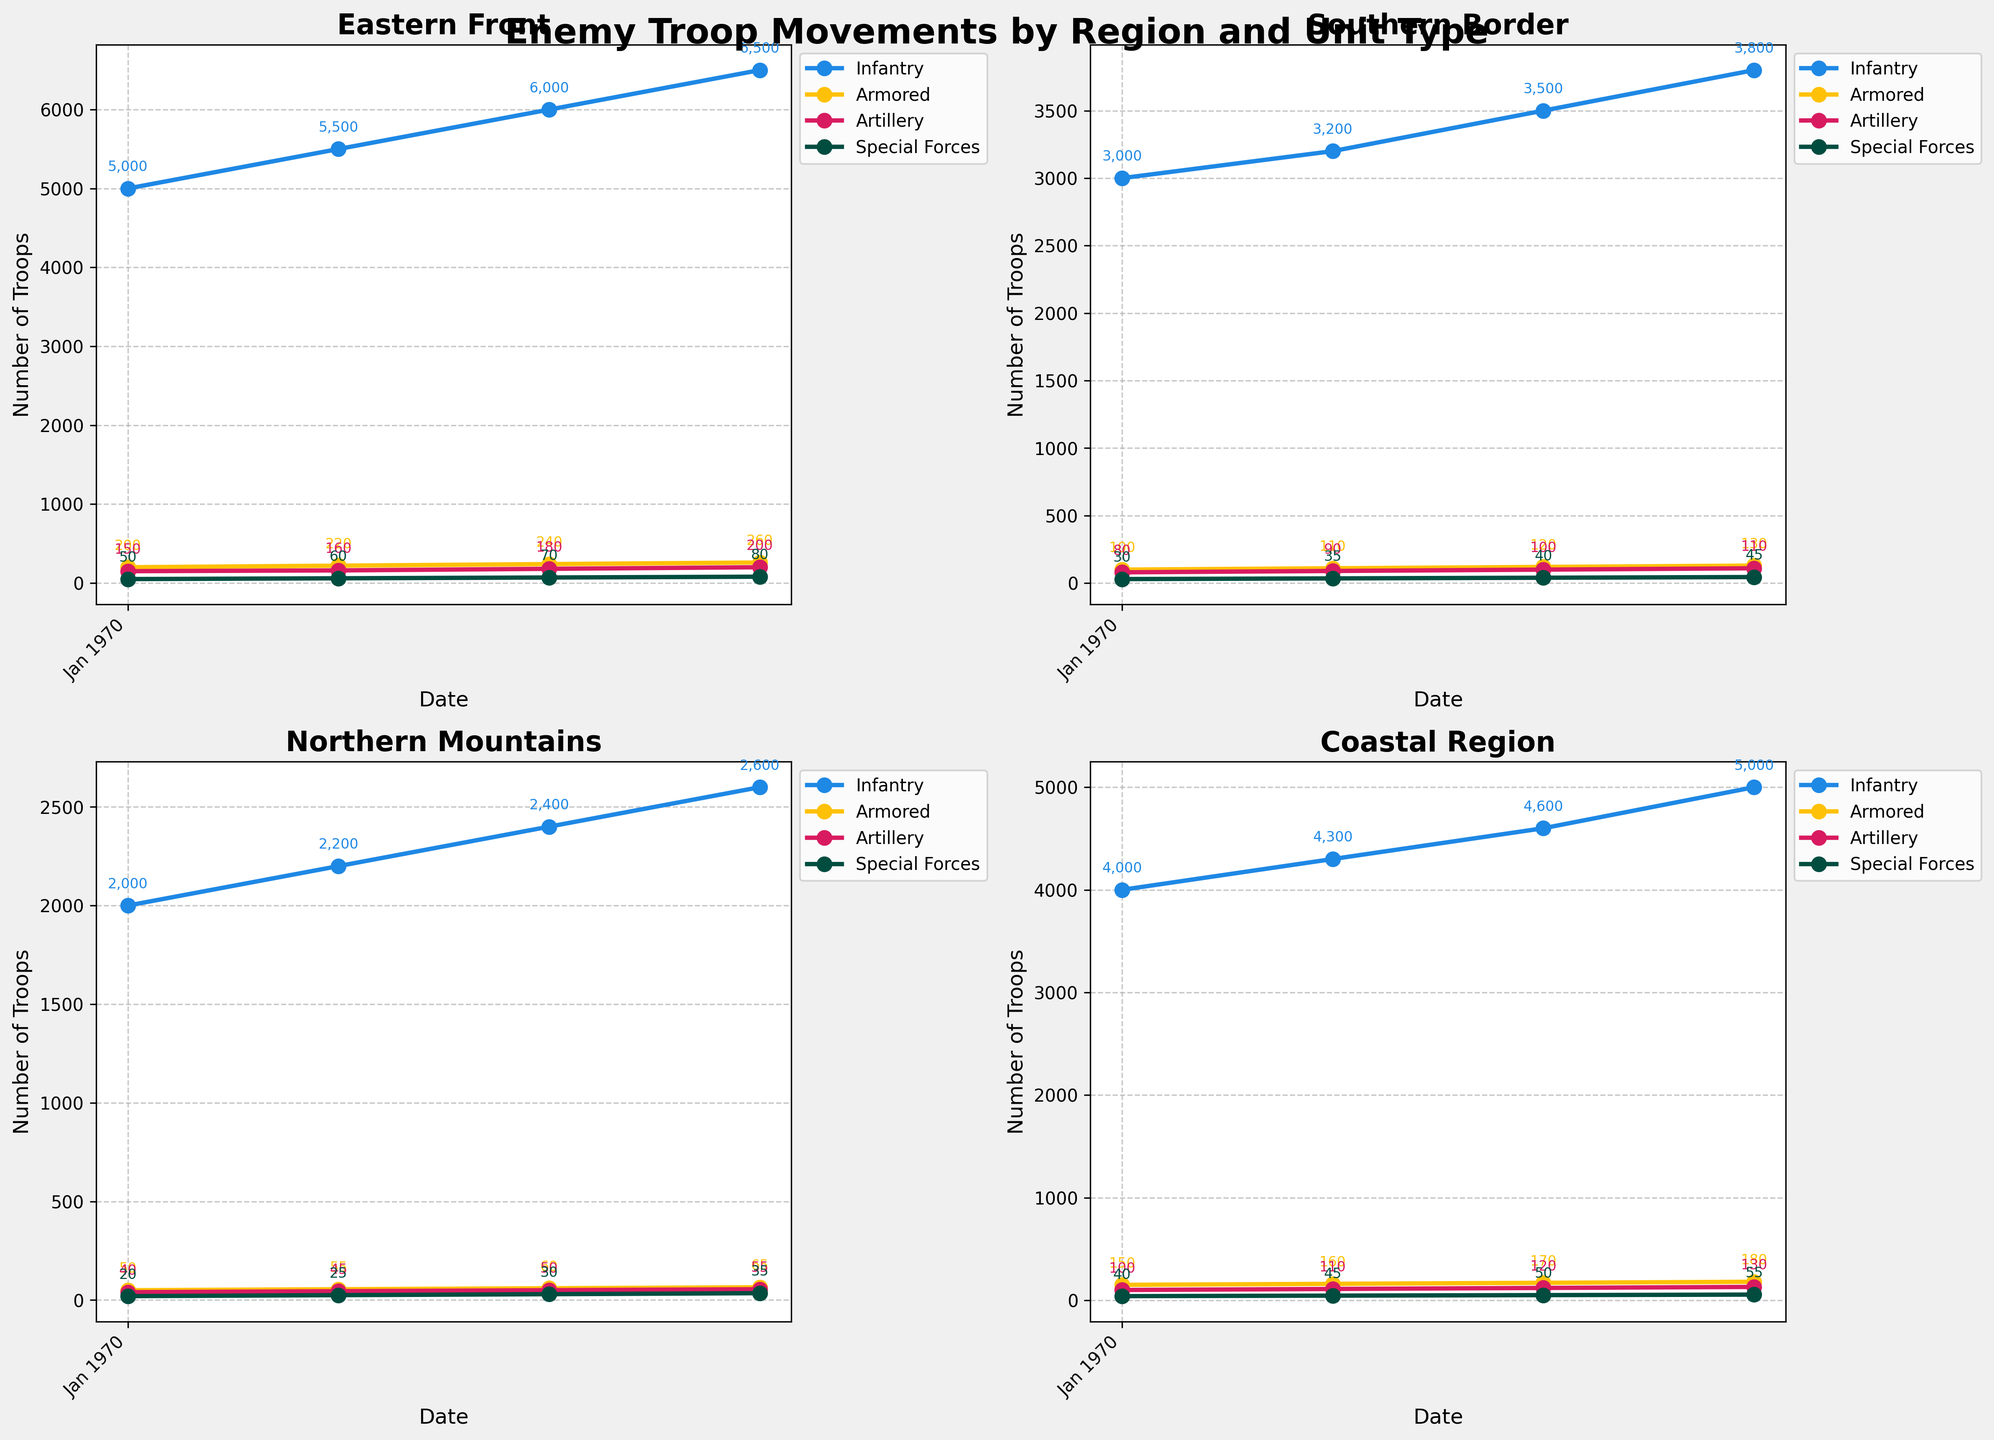What is the trend of Infantry troop movement in the Eastern Front from January to April 2023? By examining the line for Infantry in the Eastern Front subplot, we can see a steady increase from 5,000 in January to 6,500 in April.
Answer: Increasing Which region has the highest number of Armored units in April 2023? By comparing the data points for April 2023 in each subplot, the Coastal Region shows the highest number of Armored units with 180.
Answer: Coastal Region Compare the difference between the number of Artillery units in the Northern Mountains and the Southern Border in February 2023. The number of Artillery units in February 2023 is 55 in the Northern Mountains and 110 in the Southern Border. The difference is 110 - 55 = 55.
Answer: 55 What is the combined total of Special Forces units across all regions in March 2023? Sum the values in March 2023 for each region: 70 (Eastern Front) + 40 (Southern Border) + 30 (Northern Mountains) + 50 (Coastal Region) = 190.
Answer: 190 Which unit type shows the steepest upward trend in the Coastal Region over the four months? By observing the slopes of the lines in Coastal Region's subplot, the Infantry line has the steepest upward trend, increasing from 4,000 to 5,000.
Answer: Infantry In which month did the Southern Border see the largest increase in the total number of troops across all units? Calculate the total troops for each unit type and month in the Southern Border subplot. The totals are: January (3,210), February (3,435), March (3,760), April (4,085). The largest increase is February to March: 3,760 - 3,435 = 325.
Answer: March 2023 Which region had the lowest number of Infantry troops in January 2023? By comparing the Infantry values in January across different subplots, the Northern Mountains had the lowest with 2,000.
Answer: Northern Mountains Identify the unit type with the slowest growth rate in the Eastern Front from January to April 2023. Compare the slope of the lines for each unit type in the Eastern Front subplot. The Special Forces line, growing from 50 to 80, shows the slowest rate compared to others.
Answer: Special Forces Between February and March 2023, which region experienced the largest increase in the number of Armored units? Examine the increase in Armored units from February to March: Eastern Front (20), Southern Border (10), Northern Mountains (5), Coastal Region (10). The Eastern Front's increase of 20 is the largest.
Answer: Eastern Front What is the average number of Infantry troops in the Northern Mountains over the four months? Sum the Infantry values in the Northern Mountains subplot and divide by 4: (2000 + 2200 + 2400 + 2600) / 4 = 2300.
Answer: 2300 